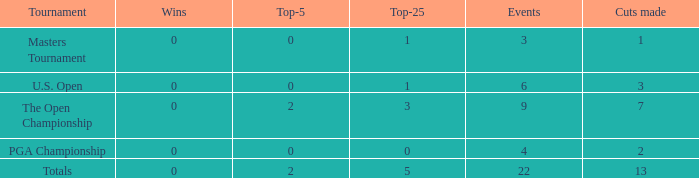Could you help me parse every detail presented in this table? {'header': ['Tournament', 'Wins', 'Top-5', 'Top-25', 'Events', 'Cuts made'], 'rows': [['Masters Tournament', '0', '0', '1', '3', '1'], ['U.S. Open', '0', '0', '1', '6', '3'], ['The Open Championship', '0', '2', '3', '9', '7'], ['PGA Championship', '0', '0', '0', '4', '2'], ['Totals', '0', '2', '5', '22', '13']]} In events with more than 0 victories and exactly 0 top-5 placements, how many cuts were made in total? 0.0. 